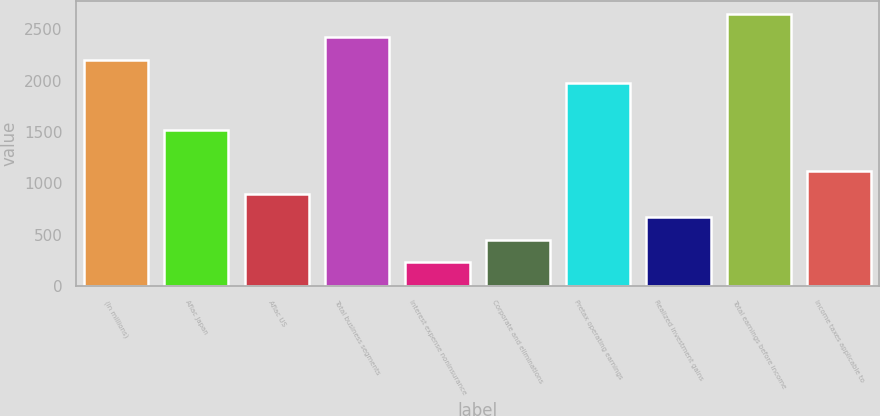<chart> <loc_0><loc_0><loc_500><loc_500><bar_chart><fcel>(In millions)<fcel>Aflac Japan<fcel>Aflac US<fcel>Total business segments<fcel>Interest expense noninsurance<fcel>Corporate and eliminations<fcel>Pretax operating earnings<fcel>Realized investment gains<fcel>Total earnings before income<fcel>Income taxes applicable to<nl><fcel>2200.8<fcel>1515<fcel>895.2<fcel>2422.6<fcel>229.8<fcel>451.6<fcel>1979<fcel>673.4<fcel>2644.4<fcel>1117<nl></chart> 